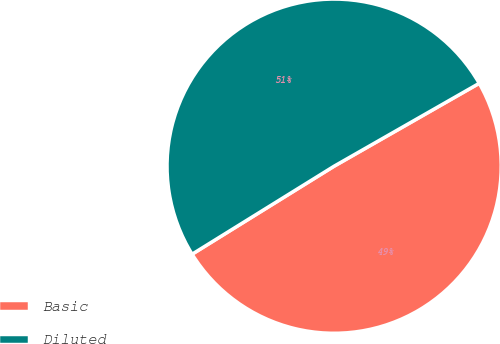Convert chart. <chart><loc_0><loc_0><loc_500><loc_500><pie_chart><fcel>Basic<fcel>Diluted<nl><fcel>49.43%<fcel>50.57%<nl></chart> 